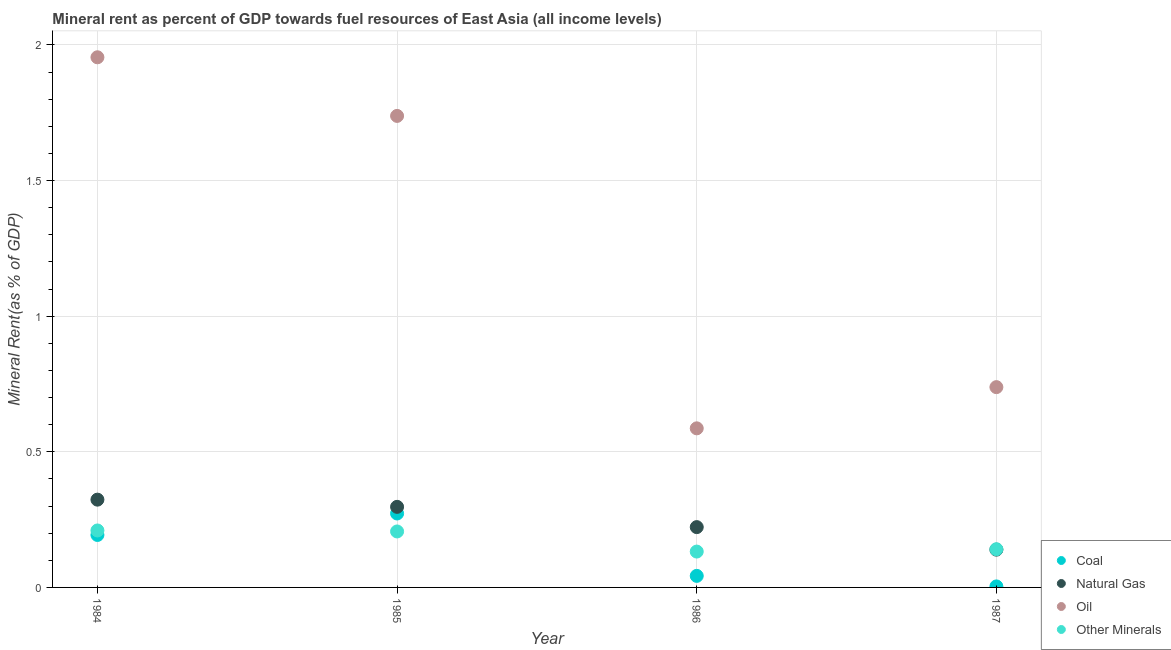How many different coloured dotlines are there?
Give a very brief answer. 4. Is the number of dotlines equal to the number of legend labels?
Give a very brief answer. Yes. What is the natural gas rent in 1987?
Your answer should be very brief. 0.14. Across all years, what is the maximum oil rent?
Keep it short and to the point. 1.95. Across all years, what is the minimum natural gas rent?
Your response must be concise. 0.14. What is the total natural gas rent in the graph?
Provide a short and direct response. 0.98. What is the difference between the coal rent in 1985 and that in 1986?
Provide a short and direct response. 0.23. What is the difference between the natural gas rent in 1985 and the oil rent in 1984?
Ensure brevity in your answer.  -1.66. What is the average coal rent per year?
Make the answer very short. 0.13. In the year 1987, what is the difference between the coal rent and oil rent?
Give a very brief answer. -0.73. In how many years, is the coal rent greater than 0.30000000000000004 %?
Offer a terse response. 0. What is the ratio of the  rent of other minerals in 1985 to that in 1987?
Your answer should be very brief. 1.46. Is the difference between the  rent of other minerals in 1984 and 1986 greater than the difference between the coal rent in 1984 and 1986?
Offer a very short reply. No. What is the difference between the highest and the second highest oil rent?
Offer a very short reply. 0.22. What is the difference between the highest and the lowest coal rent?
Your answer should be compact. 0.27. In how many years, is the oil rent greater than the average oil rent taken over all years?
Provide a short and direct response. 2. Is it the case that in every year, the sum of the  rent of other minerals and natural gas rent is greater than the sum of coal rent and oil rent?
Make the answer very short. Yes. Does the oil rent monotonically increase over the years?
Keep it short and to the point. No. Is the natural gas rent strictly greater than the oil rent over the years?
Offer a very short reply. No. Does the graph contain any zero values?
Offer a very short reply. No. What is the title of the graph?
Your answer should be compact. Mineral rent as percent of GDP towards fuel resources of East Asia (all income levels). Does "Corruption" appear as one of the legend labels in the graph?
Make the answer very short. No. What is the label or title of the Y-axis?
Offer a very short reply. Mineral Rent(as % of GDP). What is the Mineral Rent(as % of GDP) of Coal in 1984?
Your response must be concise. 0.19. What is the Mineral Rent(as % of GDP) of Natural Gas in 1984?
Make the answer very short. 0.32. What is the Mineral Rent(as % of GDP) of Oil in 1984?
Ensure brevity in your answer.  1.95. What is the Mineral Rent(as % of GDP) in Other Minerals in 1984?
Make the answer very short. 0.21. What is the Mineral Rent(as % of GDP) of Coal in 1985?
Offer a terse response. 0.27. What is the Mineral Rent(as % of GDP) in Natural Gas in 1985?
Provide a short and direct response. 0.3. What is the Mineral Rent(as % of GDP) in Oil in 1985?
Your answer should be very brief. 1.74. What is the Mineral Rent(as % of GDP) in Other Minerals in 1985?
Provide a succinct answer. 0.21. What is the Mineral Rent(as % of GDP) in Coal in 1986?
Provide a succinct answer. 0.04. What is the Mineral Rent(as % of GDP) of Natural Gas in 1986?
Your response must be concise. 0.22. What is the Mineral Rent(as % of GDP) of Oil in 1986?
Offer a terse response. 0.59. What is the Mineral Rent(as % of GDP) of Other Minerals in 1986?
Provide a succinct answer. 0.13. What is the Mineral Rent(as % of GDP) in Coal in 1987?
Make the answer very short. 0. What is the Mineral Rent(as % of GDP) of Natural Gas in 1987?
Give a very brief answer. 0.14. What is the Mineral Rent(as % of GDP) of Oil in 1987?
Your answer should be very brief. 0.74. What is the Mineral Rent(as % of GDP) of Other Minerals in 1987?
Provide a short and direct response. 0.14. Across all years, what is the maximum Mineral Rent(as % of GDP) of Coal?
Your response must be concise. 0.27. Across all years, what is the maximum Mineral Rent(as % of GDP) of Natural Gas?
Give a very brief answer. 0.32. Across all years, what is the maximum Mineral Rent(as % of GDP) in Oil?
Your answer should be compact. 1.95. Across all years, what is the maximum Mineral Rent(as % of GDP) of Other Minerals?
Your answer should be compact. 0.21. Across all years, what is the minimum Mineral Rent(as % of GDP) in Coal?
Ensure brevity in your answer.  0. Across all years, what is the minimum Mineral Rent(as % of GDP) of Natural Gas?
Ensure brevity in your answer.  0.14. Across all years, what is the minimum Mineral Rent(as % of GDP) in Oil?
Your answer should be very brief. 0.59. Across all years, what is the minimum Mineral Rent(as % of GDP) of Other Minerals?
Your response must be concise. 0.13. What is the total Mineral Rent(as % of GDP) of Coal in the graph?
Make the answer very short. 0.51. What is the total Mineral Rent(as % of GDP) of Natural Gas in the graph?
Your answer should be compact. 0.98. What is the total Mineral Rent(as % of GDP) of Oil in the graph?
Offer a very short reply. 5.02. What is the total Mineral Rent(as % of GDP) in Other Minerals in the graph?
Offer a terse response. 0.69. What is the difference between the Mineral Rent(as % of GDP) in Coal in 1984 and that in 1985?
Make the answer very short. -0.08. What is the difference between the Mineral Rent(as % of GDP) in Natural Gas in 1984 and that in 1985?
Keep it short and to the point. 0.03. What is the difference between the Mineral Rent(as % of GDP) in Oil in 1984 and that in 1985?
Offer a terse response. 0.22. What is the difference between the Mineral Rent(as % of GDP) of Other Minerals in 1984 and that in 1985?
Ensure brevity in your answer.  0. What is the difference between the Mineral Rent(as % of GDP) of Coal in 1984 and that in 1986?
Your answer should be compact. 0.15. What is the difference between the Mineral Rent(as % of GDP) in Natural Gas in 1984 and that in 1986?
Your answer should be very brief. 0.1. What is the difference between the Mineral Rent(as % of GDP) in Oil in 1984 and that in 1986?
Offer a very short reply. 1.37. What is the difference between the Mineral Rent(as % of GDP) of Other Minerals in 1984 and that in 1986?
Provide a short and direct response. 0.08. What is the difference between the Mineral Rent(as % of GDP) in Coal in 1984 and that in 1987?
Your answer should be very brief. 0.19. What is the difference between the Mineral Rent(as % of GDP) in Natural Gas in 1984 and that in 1987?
Give a very brief answer. 0.18. What is the difference between the Mineral Rent(as % of GDP) in Oil in 1984 and that in 1987?
Keep it short and to the point. 1.22. What is the difference between the Mineral Rent(as % of GDP) of Other Minerals in 1984 and that in 1987?
Ensure brevity in your answer.  0.07. What is the difference between the Mineral Rent(as % of GDP) of Coal in 1985 and that in 1986?
Offer a terse response. 0.23. What is the difference between the Mineral Rent(as % of GDP) in Natural Gas in 1985 and that in 1986?
Give a very brief answer. 0.07. What is the difference between the Mineral Rent(as % of GDP) in Oil in 1985 and that in 1986?
Your response must be concise. 1.15. What is the difference between the Mineral Rent(as % of GDP) of Other Minerals in 1985 and that in 1986?
Your answer should be very brief. 0.07. What is the difference between the Mineral Rent(as % of GDP) in Coal in 1985 and that in 1987?
Make the answer very short. 0.27. What is the difference between the Mineral Rent(as % of GDP) in Natural Gas in 1985 and that in 1987?
Offer a terse response. 0.16. What is the difference between the Mineral Rent(as % of GDP) in Other Minerals in 1985 and that in 1987?
Offer a terse response. 0.07. What is the difference between the Mineral Rent(as % of GDP) in Coal in 1986 and that in 1987?
Ensure brevity in your answer.  0.04. What is the difference between the Mineral Rent(as % of GDP) of Natural Gas in 1986 and that in 1987?
Give a very brief answer. 0.08. What is the difference between the Mineral Rent(as % of GDP) of Oil in 1986 and that in 1987?
Give a very brief answer. -0.15. What is the difference between the Mineral Rent(as % of GDP) in Other Minerals in 1986 and that in 1987?
Your response must be concise. -0.01. What is the difference between the Mineral Rent(as % of GDP) of Coal in 1984 and the Mineral Rent(as % of GDP) of Natural Gas in 1985?
Keep it short and to the point. -0.1. What is the difference between the Mineral Rent(as % of GDP) in Coal in 1984 and the Mineral Rent(as % of GDP) in Oil in 1985?
Ensure brevity in your answer.  -1.54. What is the difference between the Mineral Rent(as % of GDP) in Coal in 1984 and the Mineral Rent(as % of GDP) in Other Minerals in 1985?
Provide a short and direct response. -0.01. What is the difference between the Mineral Rent(as % of GDP) of Natural Gas in 1984 and the Mineral Rent(as % of GDP) of Oil in 1985?
Make the answer very short. -1.41. What is the difference between the Mineral Rent(as % of GDP) of Natural Gas in 1984 and the Mineral Rent(as % of GDP) of Other Minerals in 1985?
Ensure brevity in your answer.  0.12. What is the difference between the Mineral Rent(as % of GDP) in Oil in 1984 and the Mineral Rent(as % of GDP) in Other Minerals in 1985?
Offer a terse response. 1.75. What is the difference between the Mineral Rent(as % of GDP) of Coal in 1984 and the Mineral Rent(as % of GDP) of Natural Gas in 1986?
Your answer should be very brief. -0.03. What is the difference between the Mineral Rent(as % of GDP) of Coal in 1984 and the Mineral Rent(as % of GDP) of Oil in 1986?
Provide a short and direct response. -0.39. What is the difference between the Mineral Rent(as % of GDP) in Coal in 1984 and the Mineral Rent(as % of GDP) in Other Minerals in 1986?
Your answer should be compact. 0.06. What is the difference between the Mineral Rent(as % of GDP) of Natural Gas in 1984 and the Mineral Rent(as % of GDP) of Oil in 1986?
Your answer should be compact. -0.26. What is the difference between the Mineral Rent(as % of GDP) of Natural Gas in 1984 and the Mineral Rent(as % of GDP) of Other Minerals in 1986?
Offer a terse response. 0.19. What is the difference between the Mineral Rent(as % of GDP) in Oil in 1984 and the Mineral Rent(as % of GDP) in Other Minerals in 1986?
Offer a terse response. 1.82. What is the difference between the Mineral Rent(as % of GDP) of Coal in 1984 and the Mineral Rent(as % of GDP) of Natural Gas in 1987?
Your answer should be very brief. 0.05. What is the difference between the Mineral Rent(as % of GDP) of Coal in 1984 and the Mineral Rent(as % of GDP) of Oil in 1987?
Your response must be concise. -0.55. What is the difference between the Mineral Rent(as % of GDP) in Coal in 1984 and the Mineral Rent(as % of GDP) in Other Minerals in 1987?
Provide a short and direct response. 0.05. What is the difference between the Mineral Rent(as % of GDP) in Natural Gas in 1984 and the Mineral Rent(as % of GDP) in Oil in 1987?
Make the answer very short. -0.41. What is the difference between the Mineral Rent(as % of GDP) in Natural Gas in 1984 and the Mineral Rent(as % of GDP) in Other Minerals in 1987?
Provide a short and direct response. 0.18. What is the difference between the Mineral Rent(as % of GDP) in Oil in 1984 and the Mineral Rent(as % of GDP) in Other Minerals in 1987?
Your response must be concise. 1.81. What is the difference between the Mineral Rent(as % of GDP) of Coal in 1985 and the Mineral Rent(as % of GDP) of Natural Gas in 1986?
Your answer should be compact. 0.05. What is the difference between the Mineral Rent(as % of GDP) of Coal in 1985 and the Mineral Rent(as % of GDP) of Oil in 1986?
Your answer should be very brief. -0.31. What is the difference between the Mineral Rent(as % of GDP) of Coal in 1985 and the Mineral Rent(as % of GDP) of Other Minerals in 1986?
Keep it short and to the point. 0.14. What is the difference between the Mineral Rent(as % of GDP) in Natural Gas in 1985 and the Mineral Rent(as % of GDP) in Oil in 1986?
Offer a terse response. -0.29. What is the difference between the Mineral Rent(as % of GDP) in Natural Gas in 1985 and the Mineral Rent(as % of GDP) in Other Minerals in 1986?
Keep it short and to the point. 0.16. What is the difference between the Mineral Rent(as % of GDP) of Oil in 1985 and the Mineral Rent(as % of GDP) of Other Minerals in 1986?
Make the answer very short. 1.61. What is the difference between the Mineral Rent(as % of GDP) of Coal in 1985 and the Mineral Rent(as % of GDP) of Natural Gas in 1987?
Keep it short and to the point. 0.13. What is the difference between the Mineral Rent(as % of GDP) of Coal in 1985 and the Mineral Rent(as % of GDP) of Oil in 1987?
Make the answer very short. -0.47. What is the difference between the Mineral Rent(as % of GDP) in Coal in 1985 and the Mineral Rent(as % of GDP) in Other Minerals in 1987?
Ensure brevity in your answer.  0.13. What is the difference between the Mineral Rent(as % of GDP) of Natural Gas in 1985 and the Mineral Rent(as % of GDP) of Oil in 1987?
Offer a very short reply. -0.44. What is the difference between the Mineral Rent(as % of GDP) of Natural Gas in 1985 and the Mineral Rent(as % of GDP) of Other Minerals in 1987?
Provide a short and direct response. 0.16. What is the difference between the Mineral Rent(as % of GDP) of Oil in 1985 and the Mineral Rent(as % of GDP) of Other Minerals in 1987?
Offer a very short reply. 1.6. What is the difference between the Mineral Rent(as % of GDP) of Coal in 1986 and the Mineral Rent(as % of GDP) of Natural Gas in 1987?
Ensure brevity in your answer.  -0.1. What is the difference between the Mineral Rent(as % of GDP) in Coal in 1986 and the Mineral Rent(as % of GDP) in Oil in 1987?
Provide a succinct answer. -0.7. What is the difference between the Mineral Rent(as % of GDP) in Coal in 1986 and the Mineral Rent(as % of GDP) in Other Minerals in 1987?
Ensure brevity in your answer.  -0.1. What is the difference between the Mineral Rent(as % of GDP) in Natural Gas in 1986 and the Mineral Rent(as % of GDP) in Oil in 1987?
Make the answer very short. -0.52. What is the difference between the Mineral Rent(as % of GDP) in Natural Gas in 1986 and the Mineral Rent(as % of GDP) in Other Minerals in 1987?
Make the answer very short. 0.08. What is the difference between the Mineral Rent(as % of GDP) in Oil in 1986 and the Mineral Rent(as % of GDP) in Other Minerals in 1987?
Give a very brief answer. 0.45. What is the average Mineral Rent(as % of GDP) of Coal per year?
Offer a terse response. 0.13. What is the average Mineral Rent(as % of GDP) in Natural Gas per year?
Keep it short and to the point. 0.25. What is the average Mineral Rent(as % of GDP) in Oil per year?
Your response must be concise. 1.25. What is the average Mineral Rent(as % of GDP) of Other Minerals per year?
Your answer should be compact. 0.17. In the year 1984, what is the difference between the Mineral Rent(as % of GDP) of Coal and Mineral Rent(as % of GDP) of Natural Gas?
Give a very brief answer. -0.13. In the year 1984, what is the difference between the Mineral Rent(as % of GDP) of Coal and Mineral Rent(as % of GDP) of Oil?
Make the answer very short. -1.76. In the year 1984, what is the difference between the Mineral Rent(as % of GDP) of Coal and Mineral Rent(as % of GDP) of Other Minerals?
Your answer should be very brief. -0.02. In the year 1984, what is the difference between the Mineral Rent(as % of GDP) of Natural Gas and Mineral Rent(as % of GDP) of Oil?
Offer a terse response. -1.63. In the year 1984, what is the difference between the Mineral Rent(as % of GDP) of Natural Gas and Mineral Rent(as % of GDP) of Other Minerals?
Keep it short and to the point. 0.11. In the year 1984, what is the difference between the Mineral Rent(as % of GDP) of Oil and Mineral Rent(as % of GDP) of Other Minerals?
Provide a succinct answer. 1.74. In the year 1985, what is the difference between the Mineral Rent(as % of GDP) in Coal and Mineral Rent(as % of GDP) in Natural Gas?
Your answer should be very brief. -0.02. In the year 1985, what is the difference between the Mineral Rent(as % of GDP) in Coal and Mineral Rent(as % of GDP) in Oil?
Your answer should be compact. -1.47. In the year 1985, what is the difference between the Mineral Rent(as % of GDP) in Coal and Mineral Rent(as % of GDP) in Other Minerals?
Make the answer very short. 0.07. In the year 1985, what is the difference between the Mineral Rent(as % of GDP) of Natural Gas and Mineral Rent(as % of GDP) of Oil?
Your answer should be very brief. -1.44. In the year 1985, what is the difference between the Mineral Rent(as % of GDP) in Natural Gas and Mineral Rent(as % of GDP) in Other Minerals?
Provide a short and direct response. 0.09. In the year 1985, what is the difference between the Mineral Rent(as % of GDP) in Oil and Mineral Rent(as % of GDP) in Other Minerals?
Your answer should be very brief. 1.53. In the year 1986, what is the difference between the Mineral Rent(as % of GDP) of Coal and Mineral Rent(as % of GDP) of Natural Gas?
Provide a succinct answer. -0.18. In the year 1986, what is the difference between the Mineral Rent(as % of GDP) in Coal and Mineral Rent(as % of GDP) in Oil?
Give a very brief answer. -0.54. In the year 1986, what is the difference between the Mineral Rent(as % of GDP) in Coal and Mineral Rent(as % of GDP) in Other Minerals?
Offer a very short reply. -0.09. In the year 1986, what is the difference between the Mineral Rent(as % of GDP) in Natural Gas and Mineral Rent(as % of GDP) in Oil?
Ensure brevity in your answer.  -0.36. In the year 1986, what is the difference between the Mineral Rent(as % of GDP) in Natural Gas and Mineral Rent(as % of GDP) in Other Minerals?
Offer a very short reply. 0.09. In the year 1986, what is the difference between the Mineral Rent(as % of GDP) in Oil and Mineral Rent(as % of GDP) in Other Minerals?
Your response must be concise. 0.45. In the year 1987, what is the difference between the Mineral Rent(as % of GDP) in Coal and Mineral Rent(as % of GDP) in Natural Gas?
Your response must be concise. -0.14. In the year 1987, what is the difference between the Mineral Rent(as % of GDP) in Coal and Mineral Rent(as % of GDP) in Oil?
Your answer should be compact. -0.73. In the year 1987, what is the difference between the Mineral Rent(as % of GDP) in Coal and Mineral Rent(as % of GDP) in Other Minerals?
Give a very brief answer. -0.14. In the year 1987, what is the difference between the Mineral Rent(as % of GDP) of Natural Gas and Mineral Rent(as % of GDP) of Oil?
Keep it short and to the point. -0.6. In the year 1987, what is the difference between the Mineral Rent(as % of GDP) in Natural Gas and Mineral Rent(as % of GDP) in Other Minerals?
Offer a very short reply. -0. In the year 1987, what is the difference between the Mineral Rent(as % of GDP) in Oil and Mineral Rent(as % of GDP) in Other Minerals?
Offer a terse response. 0.6. What is the ratio of the Mineral Rent(as % of GDP) of Coal in 1984 to that in 1985?
Make the answer very short. 0.71. What is the ratio of the Mineral Rent(as % of GDP) of Natural Gas in 1984 to that in 1985?
Provide a short and direct response. 1.09. What is the ratio of the Mineral Rent(as % of GDP) of Oil in 1984 to that in 1985?
Provide a succinct answer. 1.12. What is the ratio of the Mineral Rent(as % of GDP) of Other Minerals in 1984 to that in 1985?
Offer a terse response. 1.02. What is the ratio of the Mineral Rent(as % of GDP) of Coal in 1984 to that in 1986?
Offer a very short reply. 4.54. What is the ratio of the Mineral Rent(as % of GDP) of Natural Gas in 1984 to that in 1986?
Your answer should be compact. 1.46. What is the ratio of the Mineral Rent(as % of GDP) in Oil in 1984 to that in 1986?
Offer a very short reply. 3.33. What is the ratio of the Mineral Rent(as % of GDP) in Other Minerals in 1984 to that in 1986?
Provide a succinct answer. 1.59. What is the ratio of the Mineral Rent(as % of GDP) of Coal in 1984 to that in 1987?
Offer a very short reply. 51.8. What is the ratio of the Mineral Rent(as % of GDP) of Natural Gas in 1984 to that in 1987?
Ensure brevity in your answer.  2.32. What is the ratio of the Mineral Rent(as % of GDP) of Oil in 1984 to that in 1987?
Your response must be concise. 2.65. What is the ratio of the Mineral Rent(as % of GDP) of Other Minerals in 1984 to that in 1987?
Offer a very short reply. 1.49. What is the ratio of the Mineral Rent(as % of GDP) in Coal in 1985 to that in 1986?
Your response must be concise. 6.4. What is the ratio of the Mineral Rent(as % of GDP) in Natural Gas in 1985 to that in 1986?
Keep it short and to the point. 1.34. What is the ratio of the Mineral Rent(as % of GDP) in Oil in 1985 to that in 1986?
Provide a succinct answer. 2.96. What is the ratio of the Mineral Rent(as % of GDP) of Other Minerals in 1985 to that in 1986?
Give a very brief answer. 1.56. What is the ratio of the Mineral Rent(as % of GDP) in Coal in 1985 to that in 1987?
Your answer should be very brief. 73. What is the ratio of the Mineral Rent(as % of GDP) of Natural Gas in 1985 to that in 1987?
Your answer should be very brief. 2.13. What is the ratio of the Mineral Rent(as % of GDP) in Oil in 1985 to that in 1987?
Offer a very short reply. 2.35. What is the ratio of the Mineral Rent(as % of GDP) of Other Minerals in 1985 to that in 1987?
Keep it short and to the point. 1.46. What is the ratio of the Mineral Rent(as % of GDP) of Coal in 1986 to that in 1987?
Keep it short and to the point. 11.4. What is the ratio of the Mineral Rent(as % of GDP) in Natural Gas in 1986 to that in 1987?
Provide a short and direct response. 1.6. What is the ratio of the Mineral Rent(as % of GDP) of Oil in 1986 to that in 1987?
Keep it short and to the point. 0.79. What is the ratio of the Mineral Rent(as % of GDP) of Other Minerals in 1986 to that in 1987?
Provide a short and direct response. 0.94. What is the difference between the highest and the second highest Mineral Rent(as % of GDP) in Coal?
Provide a short and direct response. 0.08. What is the difference between the highest and the second highest Mineral Rent(as % of GDP) of Natural Gas?
Provide a succinct answer. 0.03. What is the difference between the highest and the second highest Mineral Rent(as % of GDP) in Oil?
Your answer should be compact. 0.22. What is the difference between the highest and the second highest Mineral Rent(as % of GDP) in Other Minerals?
Your answer should be compact. 0. What is the difference between the highest and the lowest Mineral Rent(as % of GDP) of Coal?
Give a very brief answer. 0.27. What is the difference between the highest and the lowest Mineral Rent(as % of GDP) in Natural Gas?
Make the answer very short. 0.18. What is the difference between the highest and the lowest Mineral Rent(as % of GDP) in Oil?
Offer a terse response. 1.37. What is the difference between the highest and the lowest Mineral Rent(as % of GDP) of Other Minerals?
Make the answer very short. 0.08. 